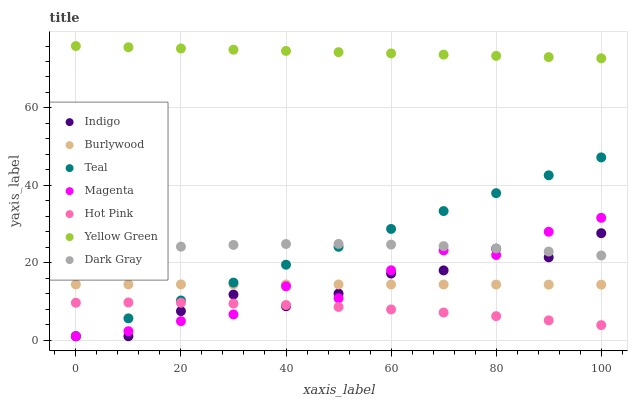Does Hot Pink have the minimum area under the curve?
Answer yes or no. Yes. Does Yellow Green have the maximum area under the curve?
Answer yes or no. Yes. Does Burlywood have the minimum area under the curve?
Answer yes or no. No. Does Burlywood have the maximum area under the curve?
Answer yes or no. No. Is Teal the smoothest?
Answer yes or no. Yes. Is Indigo the roughest?
Answer yes or no. Yes. Is Yellow Green the smoothest?
Answer yes or no. No. Is Yellow Green the roughest?
Answer yes or no. No. Does Indigo have the lowest value?
Answer yes or no. Yes. Does Burlywood have the lowest value?
Answer yes or no. No. Does Yellow Green have the highest value?
Answer yes or no. Yes. Does Burlywood have the highest value?
Answer yes or no. No. Is Hot Pink less than Yellow Green?
Answer yes or no. Yes. Is Yellow Green greater than Hot Pink?
Answer yes or no. Yes. Does Hot Pink intersect Indigo?
Answer yes or no. Yes. Is Hot Pink less than Indigo?
Answer yes or no. No. Is Hot Pink greater than Indigo?
Answer yes or no. No. Does Hot Pink intersect Yellow Green?
Answer yes or no. No. 